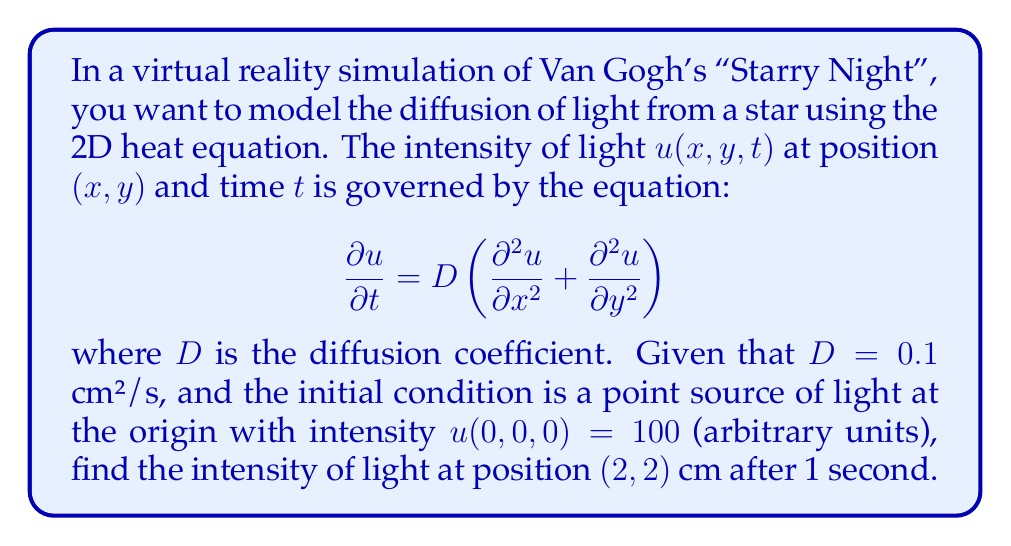Give your solution to this math problem. To solve this problem, we need to use the fundamental solution of the 2D heat equation, which is given by:

$$u(x,y,t) = \frac{M}{4\pi Dt} \exp\left(-\frac{x^2 + y^2}{4Dt}\right)$$

where $M$ is the initial total amount of substance (in our case, light intensity).

Let's follow these steps:

1) First, we need to find $M$. Since we have a point source at the origin with intensity 100, $M = 100$.

2) We're given $D = 0.1$ cm²/s, $t = 1$ s, and we want to find the intensity at $(x,y) = (2,2)$ cm.

3) Let's substitute these values into the fundamental solution:

   $$u(2,2,1) = \frac{100}{4\pi(0.1)(1)} \exp\left(-\frac{2^2 + 2^2}{4(0.1)(1)}\right)$$

4) Simplify the fraction in front:
   
   $$u(2,2,1) = \frac{100}{1.256} \exp\left(-\frac{8}{0.4}\right)$$

5) Simplify inside the exponential:
   
   $$u(2,2,1) = 79.617 \exp(-20)$$

6) Calculate the final result:
   
   $$u(2,2,1) \approx 79.617 \times 2.061 \times 10^{-9} \approx 1.64 \times 10^{-7}$$

Therefore, the intensity of light at position (2,2) cm after 1 second is approximately $1.64 \times 10^{-7}$ arbitrary units.
Answer: $1.64 \times 10^{-7}$ arbitrary units 